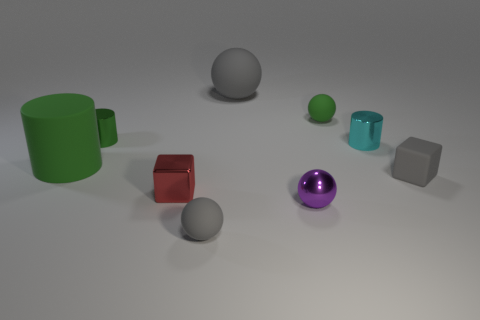I'm trying to understand the arrangement of objects. Could you explain which object is at the center and what surrounds it? At the center of the image lies a reflective purple sphere. It is encircled by a mix of other three-dimensional shapes, each at various distances and positions relative to this central object, creating an interesting study in spatial relation and composition. 